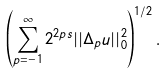Convert formula to latex. <formula><loc_0><loc_0><loc_500><loc_500>\left ( \sum _ { p = - 1 } ^ { \infty } 2 ^ { 2 p s } | | \Delta _ { p } u | | _ { 0 } ^ { 2 } \right ) ^ { 1 / 2 } .</formula> 